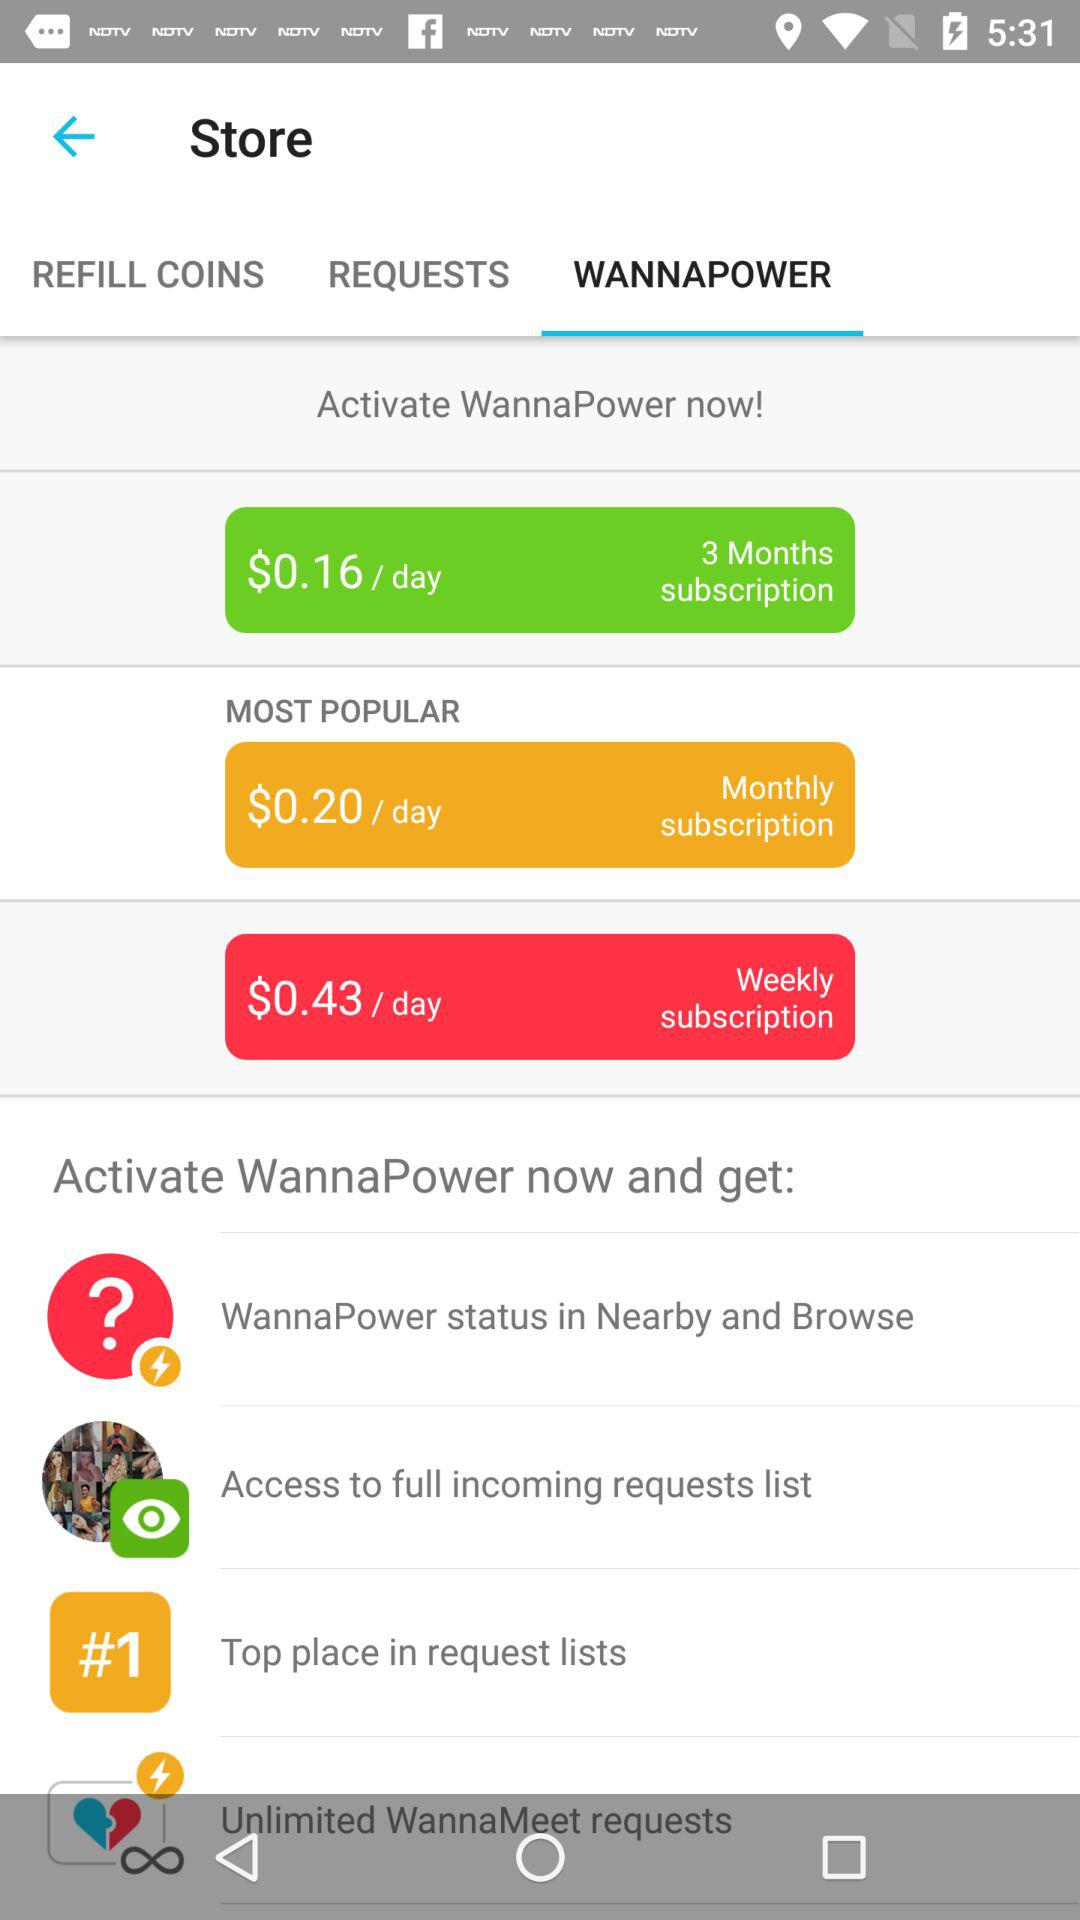What is the most popular plan? The most popular plan is "$0.20 / day". 